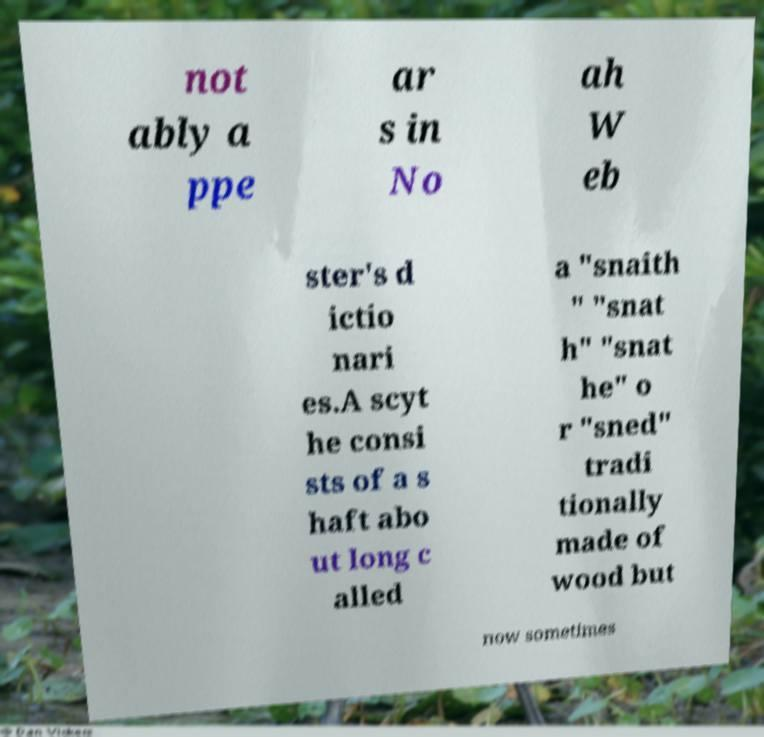Please identify and transcribe the text found in this image. not ably a ppe ar s in No ah W eb ster's d ictio nari es.A scyt he consi sts of a s haft abo ut long c alled a "snaith " "snat h" "snat he" o r "sned" tradi tionally made of wood but now sometimes 